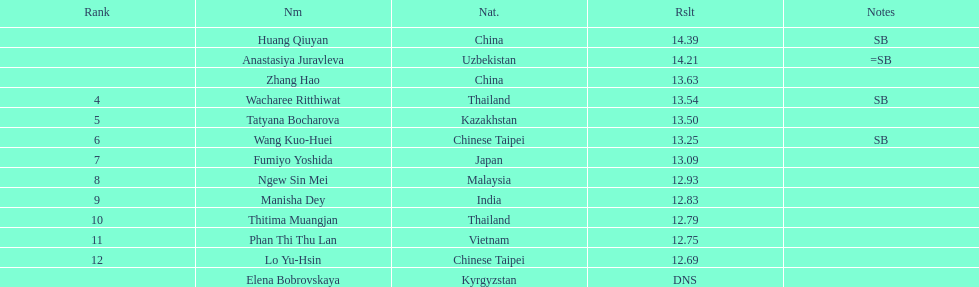What is the difference between huang qiuyan's result and fumiyo yoshida's result? 1.3. 